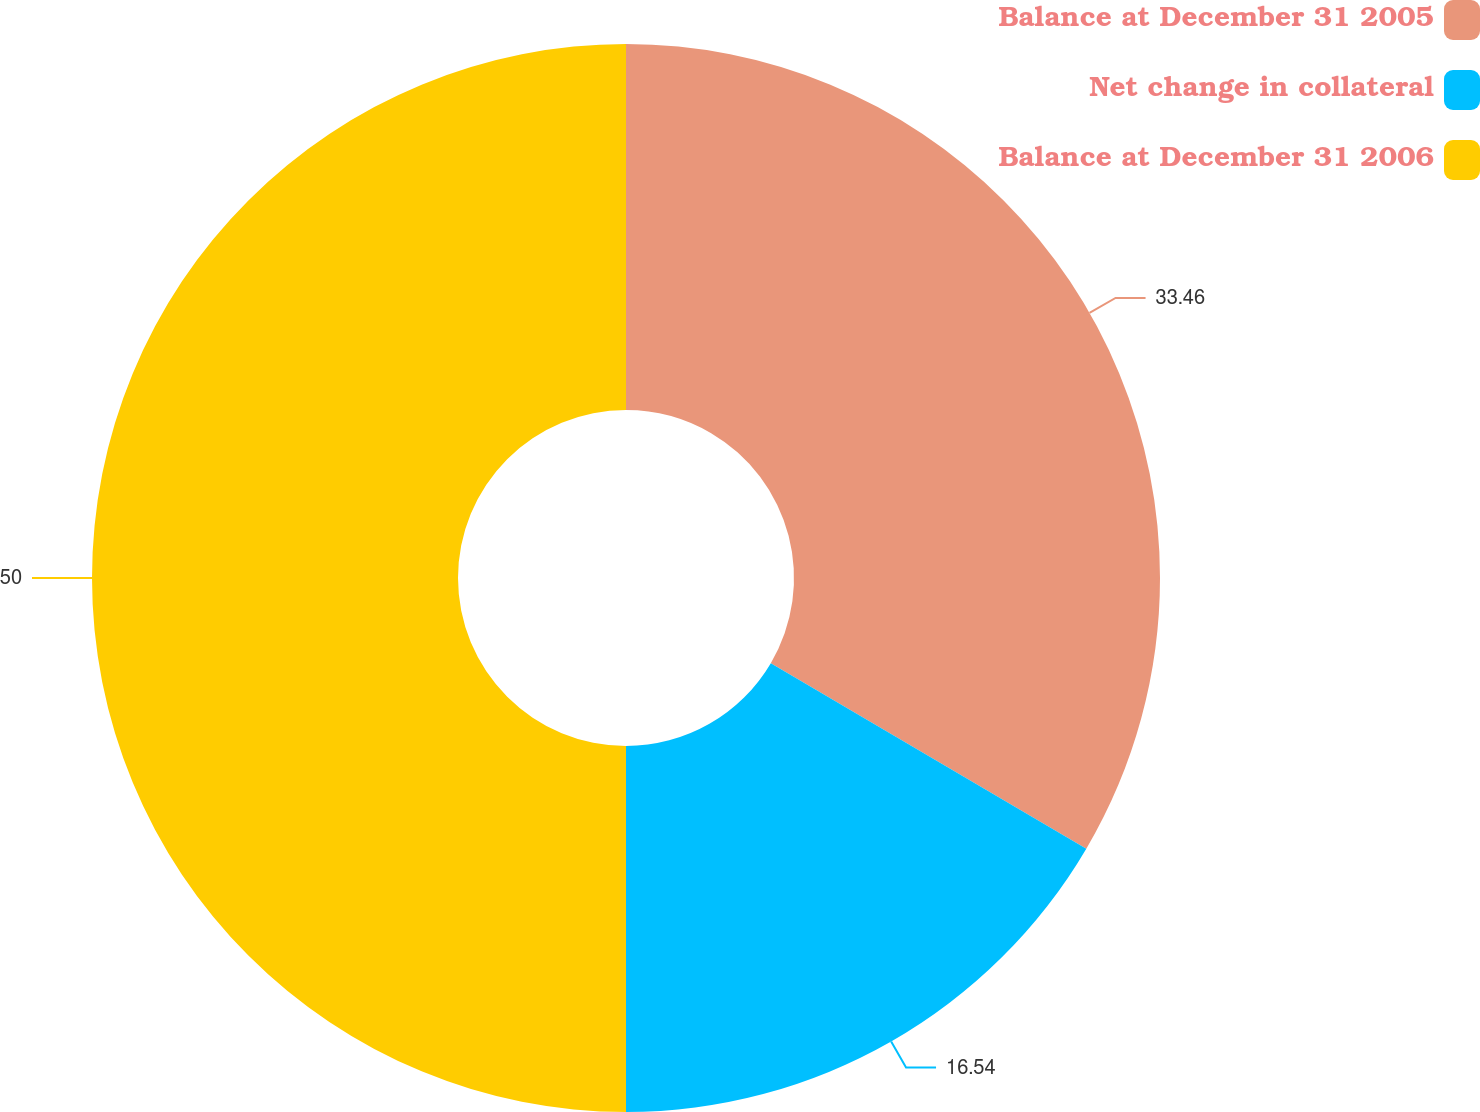Convert chart. <chart><loc_0><loc_0><loc_500><loc_500><pie_chart><fcel>Balance at December 31 2005<fcel>Net change in collateral<fcel>Balance at December 31 2006<nl><fcel>33.46%<fcel>16.54%<fcel>50.0%<nl></chart> 